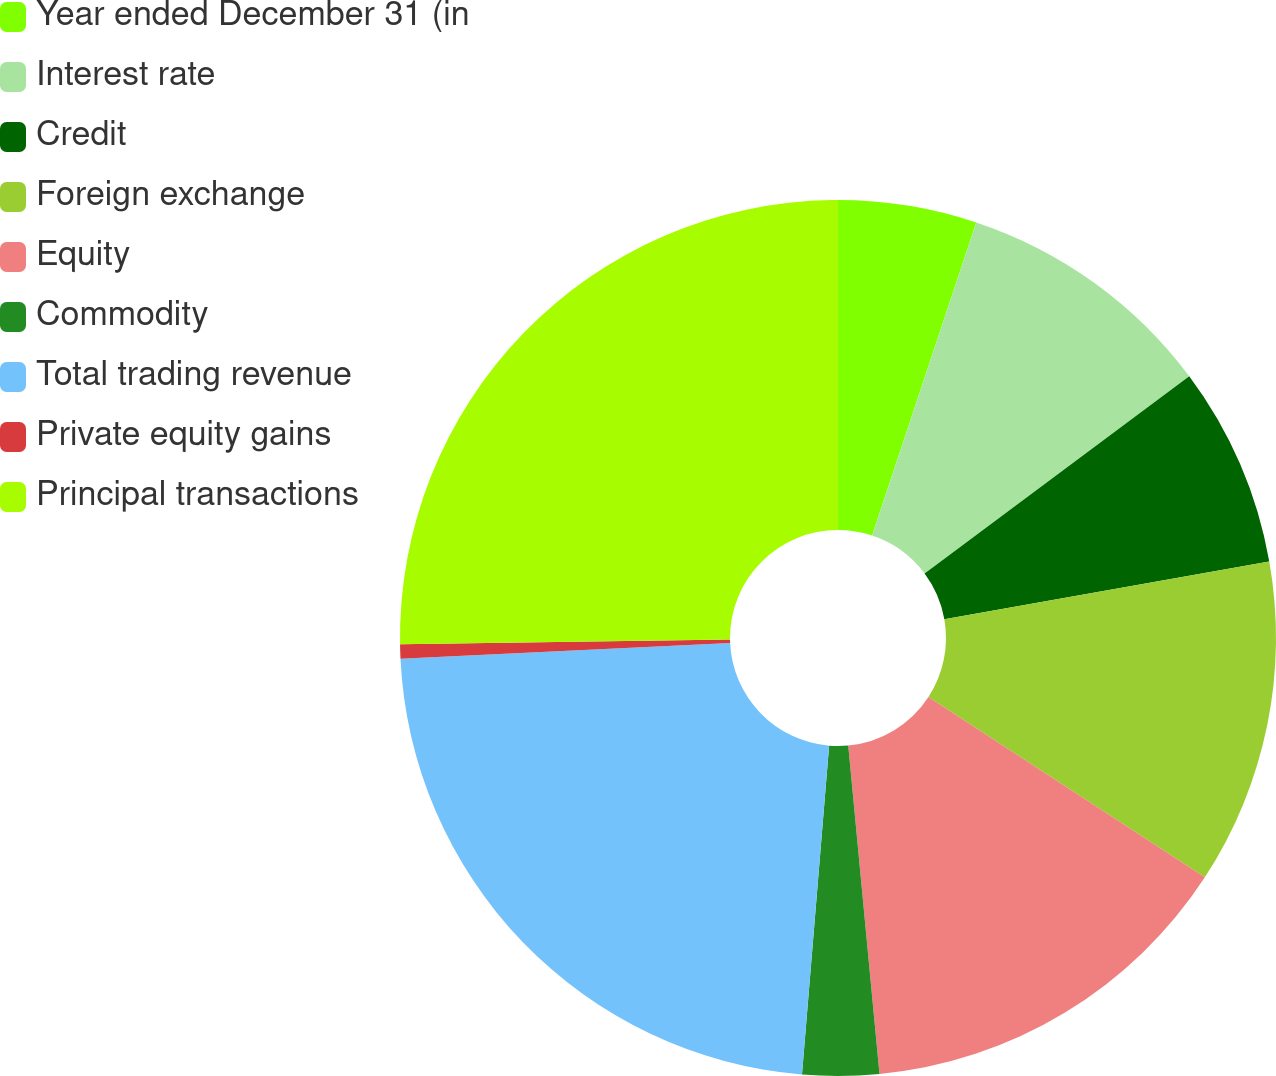<chart> <loc_0><loc_0><loc_500><loc_500><pie_chart><fcel>Year ended December 31 (in<fcel>Interest rate<fcel>Credit<fcel>Foreign exchange<fcel>Equity<fcel>Commodity<fcel>Total trading revenue<fcel>Private equity gains<fcel>Principal transactions<nl><fcel>5.11%<fcel>9.7%<fcel>7.4%<fcel>11.99%<fcel>14.29%<fcel>2.82%<fcel>22.94%<fcel>0.52%<fcel>25.23%<nl></chart> 